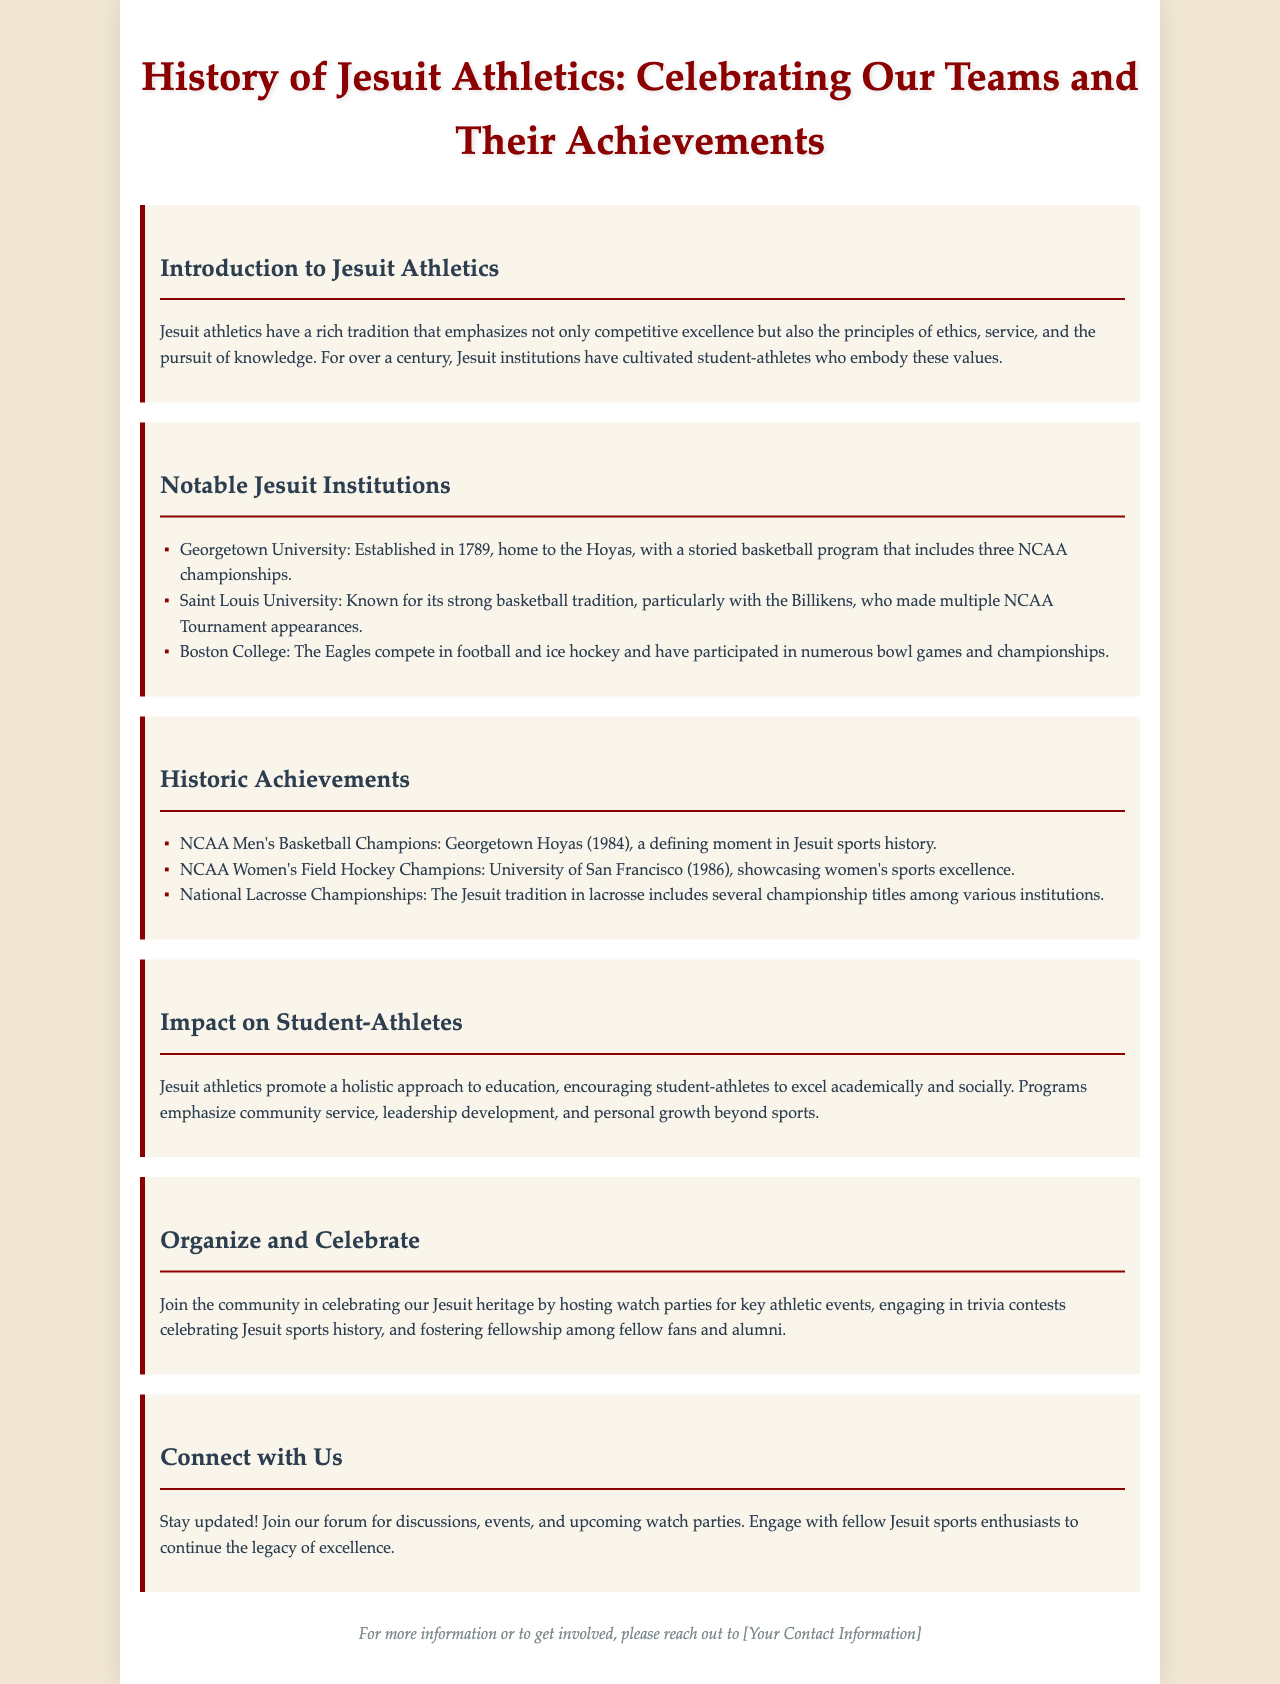What year was Georgetown University established? The document states that Georgetown University was established in 1789.
Answer: 1789 What is the nickname of the basketball team at Saint Louis University? The document refers to Saint Louis University's basketball team as the Billikens.
Answer: Billikens Which Jesuit institution won the NCAA Men's Basketball Championship in 1984? The document indicates that the Georgetown Hoyas won the NCAA Men's Basketball Championship in 1984.
Answer: Georgetown Hoyas What year did the University of San Francisco win the NCAA Women's Field Hockey Championship? According to the document, the University of San Francisco won the NCAA Women's Field Hockey Championship in 1986.
Answer: 1986 What are the key values emphasized by Jesuit athletics? The document mentions principles of ethics, service, and the pursuit of knowledge as key values.
Answer: ethics, service, pursuit of knowledge How does Jesuit athletics impact student-athletes? The document explains that Jesuit athletics promote a holistic approach, including academic and social excellence.
Answer: holistic approach What activities are suggested for celebrating Jesuit heritage? The document mentions hosting watch parties and engaging in trivia contests among other activities.
Answer: watch parties, trivia contests How can individuals connect with the Jesuit sports community? The document suggests joining a forum for discussions, events, and watch parties to connect.
Answer: join our forum What does the footer of the document provide? The footer includes a note for more information or to get involved, along with a placeholder for contact information.
Answer: contact information 